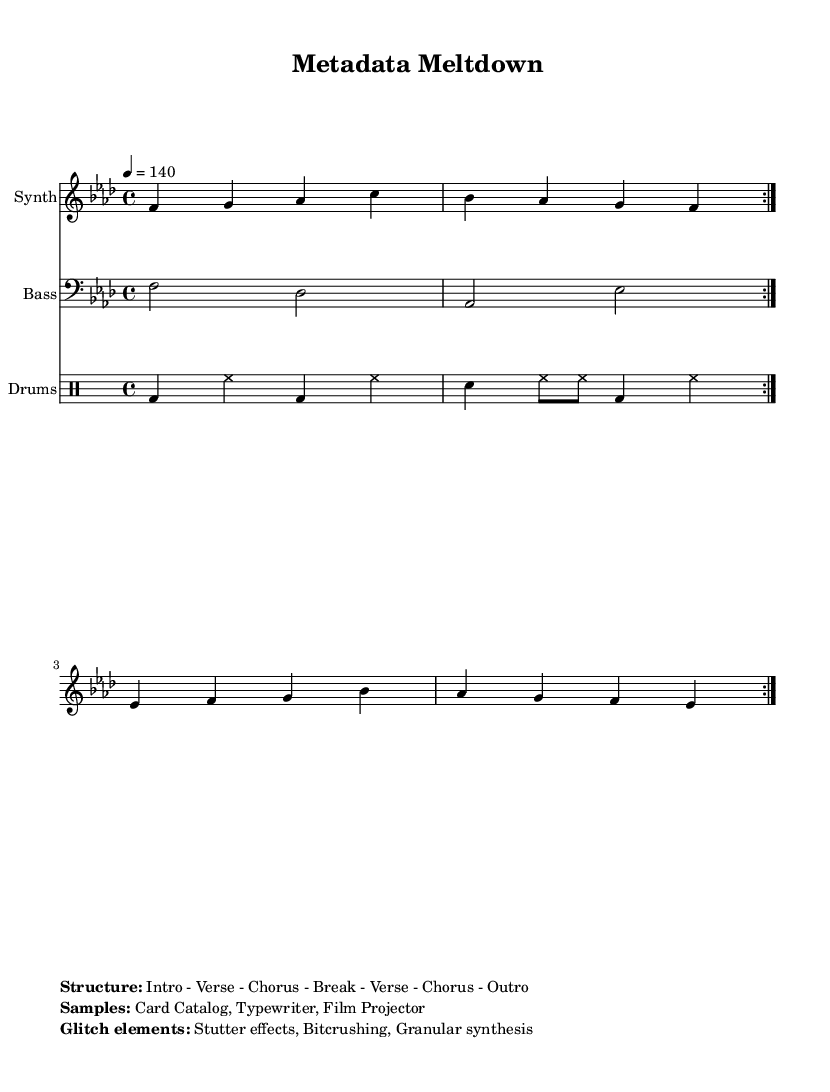What is the key signature of this music? The key signature is defined at the beginning of the piece. It indicates F minor, which contains four flats: B, E, A, and D.
Answer: F minor What is the time signature of this music? The time signature is indicated by the numbers at the beginning. Here, it shows 4/4, meaning there are four beats in each measure and the quarter note gets one beat.
Answer: 4/4 What is the tempo marking for this music? The tempo marking is found within the global settings and indicates a speed of 140 beats per minute.
Answer: 140 What is the structure of the piece? The structure is provided in the markup section. It lists the components of the music: Intro, Verse, Chorus, Break, Verse, Chorus, Outro.
Answer: Intro - Verse - Chorus - Break - Verse - Chorus - Outro What types of samples are incorporated into this track? The samples are listed in the markup section as "Card Catalog," "Typewriter," and "Film Projector."
Answer: Card Catalog, Typewriter, Film Projector What glitch elements are present in the track? The glitch elements are noted in the markup. They include "Stutter effects," "Bitcrushing," and "Granular synthesis," which are common in glitch-hop music.
Answer: Stutter effects, Bitcrushing, Granular synthesis How many times is the main synth melody repeated? The repeated sections are indicated in the synth part. The instructions state "repeat volta 2," meaning the melody is played two times.
Answer: 2 